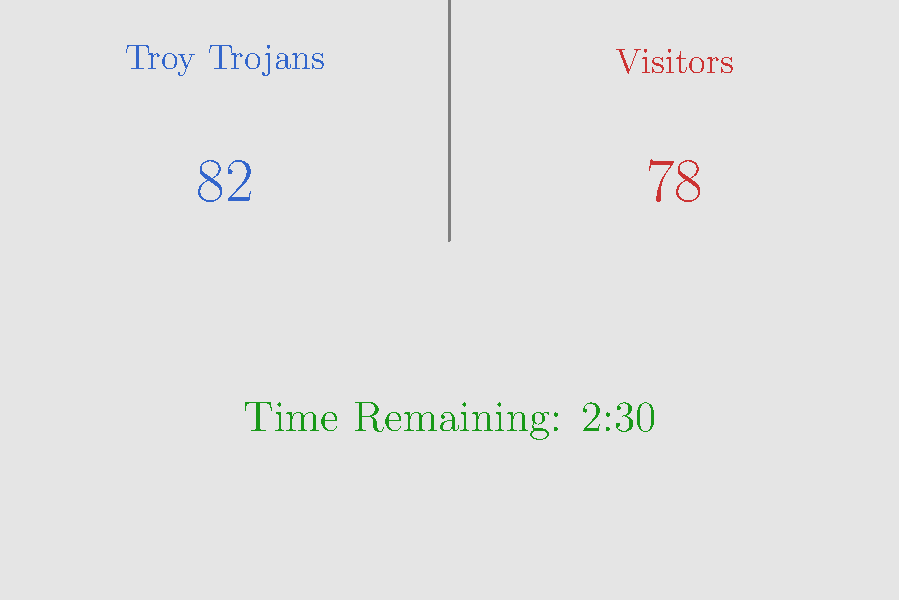Looking at the basketball scoreboard shown above, which team is currently winning the game? To determine which team is winning, we need to compare the scores of both teams:

1. Identify the teams:
   - Troy Trojans (left side)
   - Visitors (right side)

2. Compare the scores:
   - Troy Trojans: 82 points
   - Visitors: 78 points

3. The team with the higher score is winning:
   82 is greater than 78, so the Troy Trojans are currently winning.

4. Note: The time remaining (2:30) doesn't affect which team is currently winning, but it indicates that the game is not over yet, and the score could still change.
Answer: Troy Trojans 